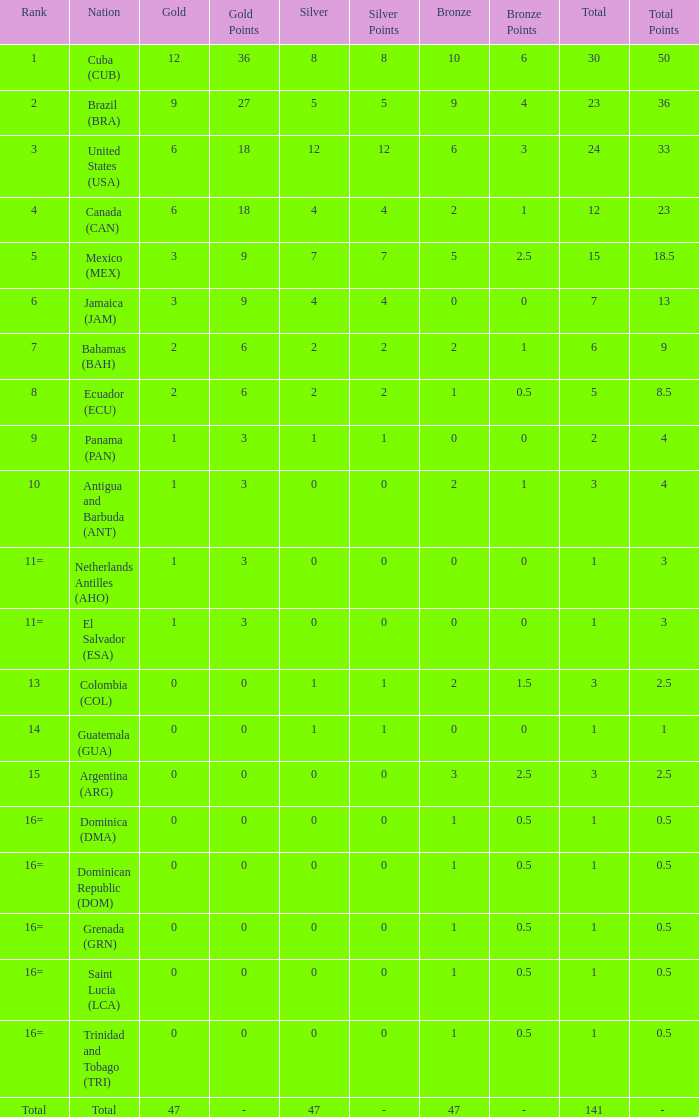How many bronzes have a Nation of jamaica (jam), and a Total smaller than 7? 0.0. 